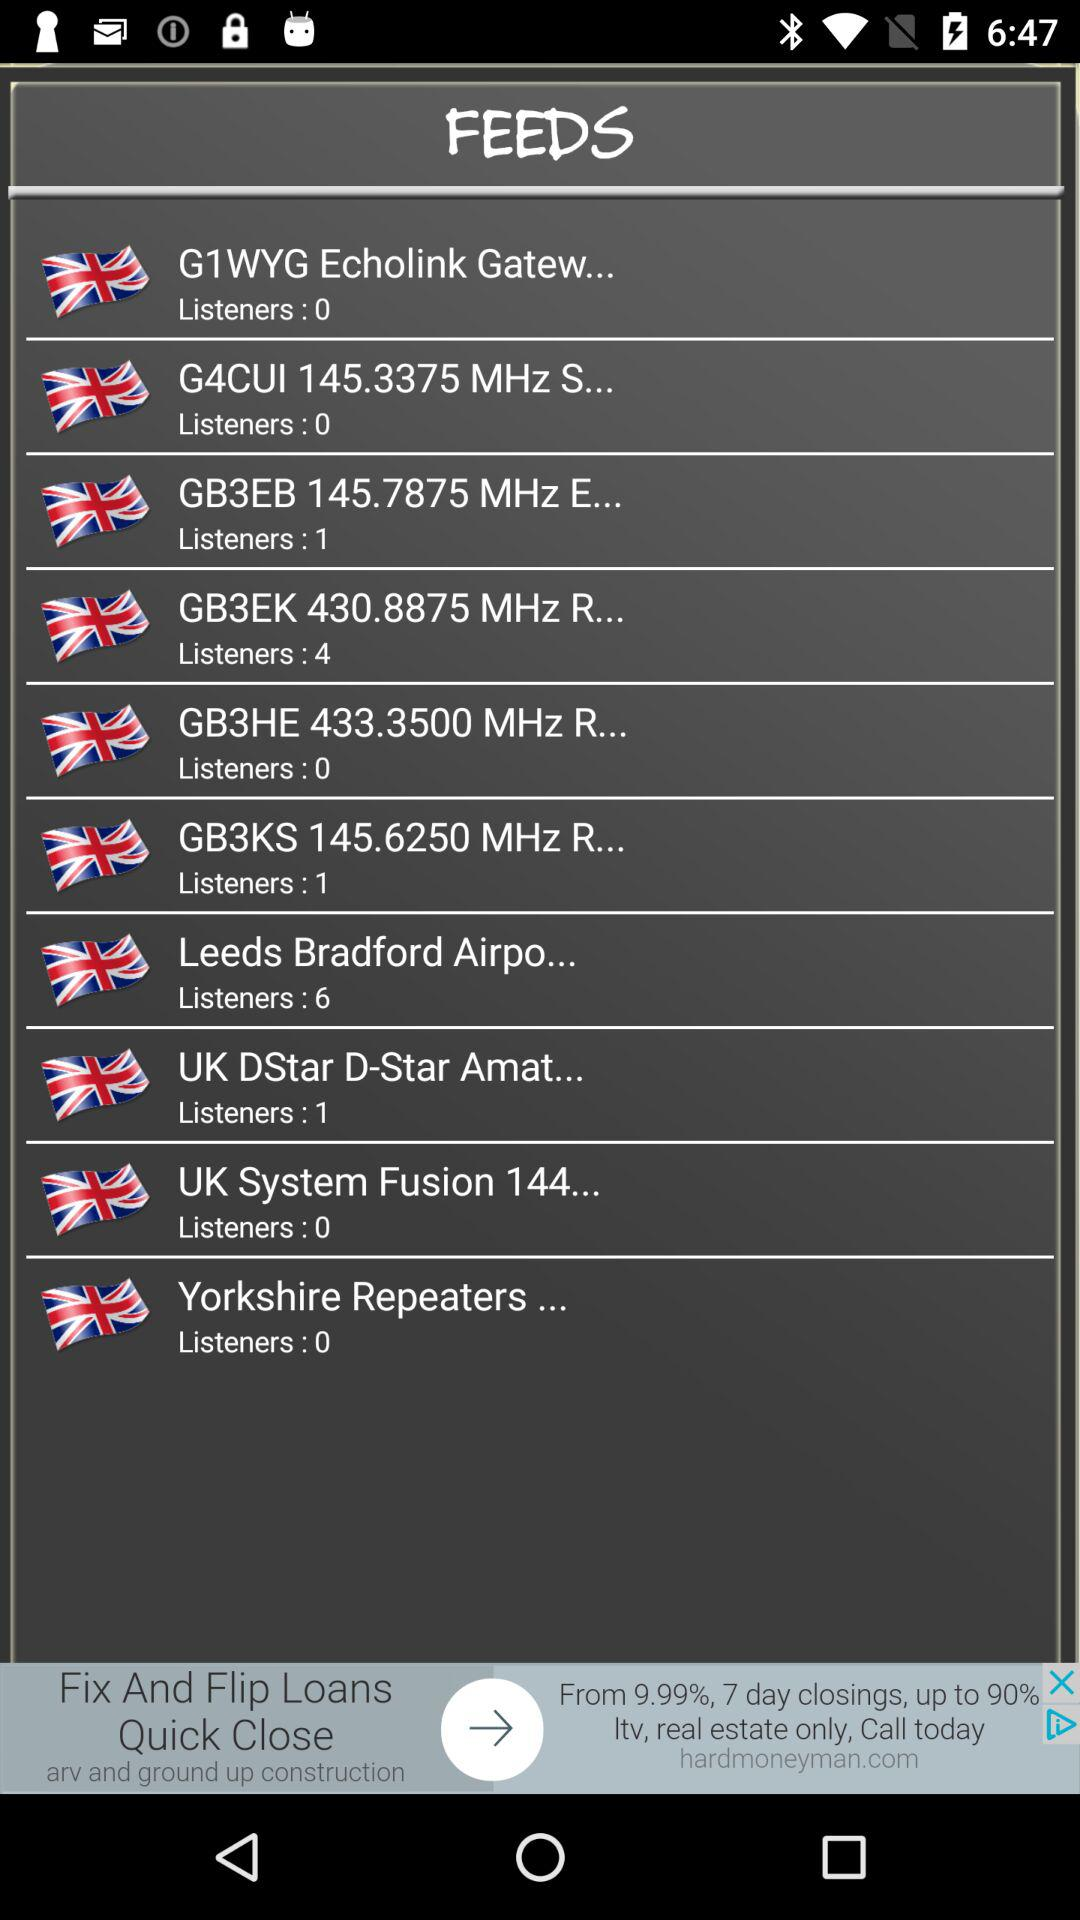How many listeners are there for "Yorkshire Repeaters..."? There are 0 listeners. 